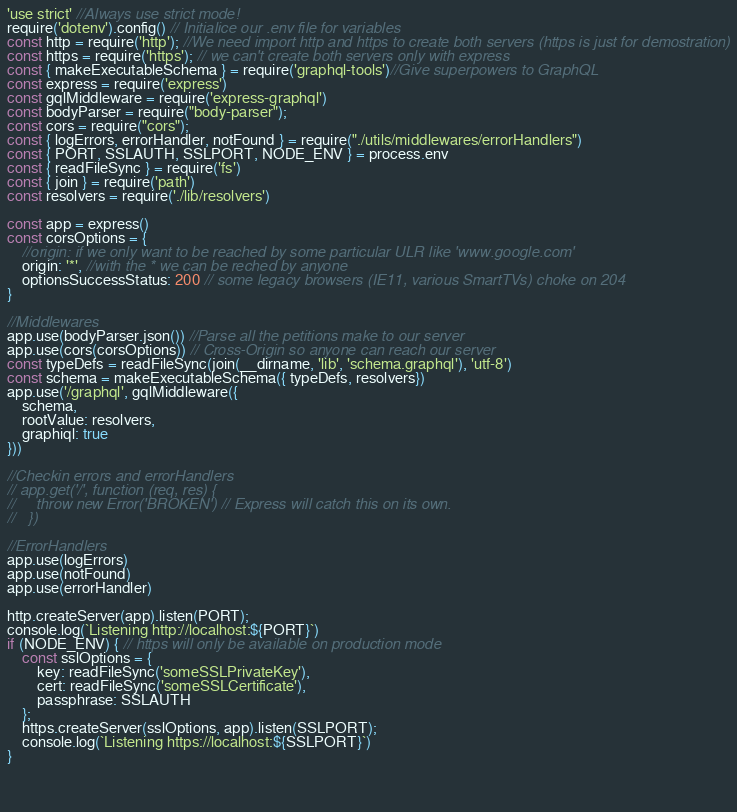<code> <loc_0><loc_0><loc_500><loc_500><_JavaScript_>'use strict' //Always use strict mode!
require('dotenv').config() // Initialice our .env file for variables
const http = require('http'); //We need import http and https to create both servers (https is just for demostration)
const https = require('https'); // we can't create both servers only with express
const { makeExecutableSchema } = require('graphql-tools')//Give superpowers to GraphQL
const express = require('express')
const gqlMiddleware = require('express-graphql')
const bodyParser = require("body-parser");
const cors = require("cors");
const { logErrors, errorHandler, notFound } = require("./utils/middlewares/errorHandlers")
const { PORT, SSLAUTH, SSLPORT, NODE_ENV } = process.env
const { readFileSync } = require('fs')
const { join } = require('path')
const resolvers = require('./lib/resolvers')

const app = express()
const corsOptions = {
    //origin: if we only want to be reached by some particular ULR like 'www.google.com'
    origin: '*', //with the * we can be reched by anyone
    optionsSuccessStatus: 200 // some legacy browsers (IE11, various SmartTVs) choke on 204
}

//Middlewares
app.use(bodyParser.json()) //Parse all the petitions make to our server
app.use(cors(corsOptions)) // Cross-Origin so anyone can reach our server
const typeDefs = readFileSync(join(__dirname, 'lib', 'schema.graphql'), 'utf-8')
const schema = makeExecutableSchema({ typeDefs, resolvers})
app.use('/graphql', gqlMiddleware({
    schema,
    rootValue: resolvers,
    graphiql: true
}))

//Checkin errors and errorHandlers
// app.get('/', function (req, res) {
//     throw new Error('BROKEN') // Express will catch this on its own.
//   })

//ErrorHandlers 
app.use(logErrors)
app.use(notFound)
app.use(errorHandler)

http.createServer(app).listen(PORT);
console.log(`Listening http://localhost:${PORT}`)
if (NODE_ENV) { // https will only be available on production mode
    const sslOptions = {
        key: readFileSync('someSSLPrivateKey'),
        cert: readFileSync('someSSLCertificate'),
        passphrase: SSLAUTH
    };
    https.createServer(sslOptions, app).listen(SSLPORT);
    console.log(`Listening https://localhost:${SSLPORT}`)
}
    

    </code> 